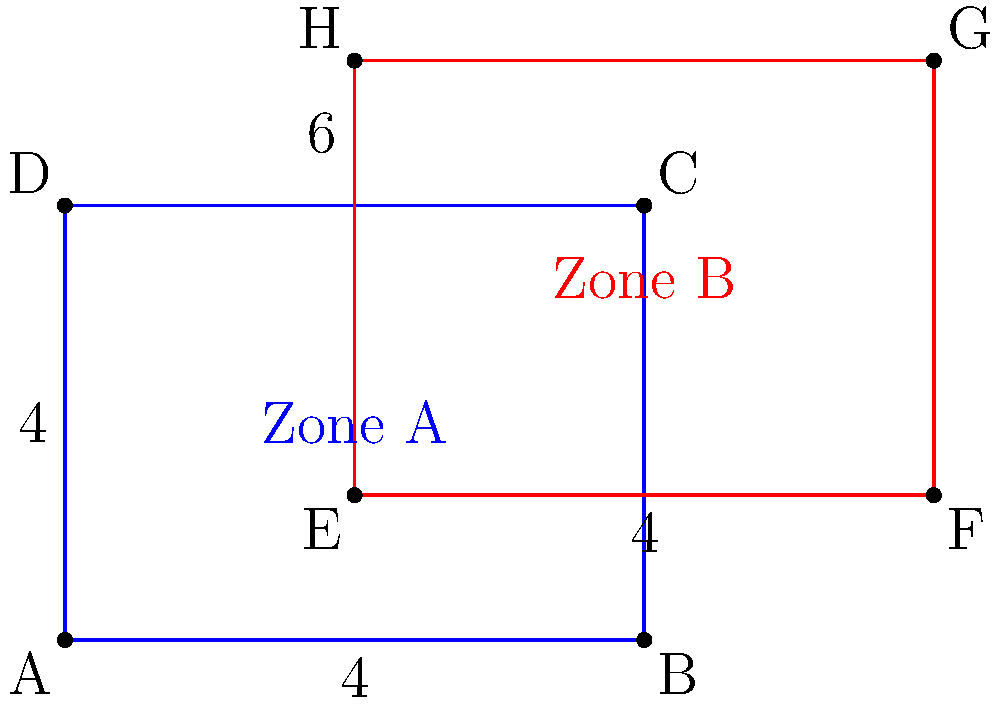In a constitutional law case involving freedom of assembly, two groups have been granted overlapping protest permit zones. Zone A is represented by the blue rectangle, and Zone B is represented by the red rectangle. Each zone is 8 units wide and 6 units tall. Zone B is shifted 4 units to the right and 2 units up relative to Zone A. What is the area of the overlapping region where both groups are permitted to protest? To find the area of overlap between the two protest permit zones, we need to follow these steps:

1) First, identify the dimensions of the overlapping region:
   - Width: The overlap starts 4 units from the left of Zone A and extends to its right edge, so the width is $8 - 4 = 4$ units.
   - Height: The overlap starts at the bottom of Zone B and extends to the top of Zone A, so the height is $6 - 2 = 4$ units.

2) The overlapping region forms a rectangle with these dimensions:
   - Width = 4 units
   - Height = 4 units

3) To calculate the area of a rectangle, we use the formula:
   $A = l \times w$
   where $A$ is the area, $l$ is the length (height in this case), and $w$ is the width.

4) Plugging in our values:
   $A = 4 \times 4 = 16$

Therefore, the area of the overlapping region is 16 square units.

This overlap represents the area where both groups have the constitutional right to assemble and protest, highlighting the complexities that can arise when balancing the rights of multiple groups in public spaces.
Answer: 16 square units 